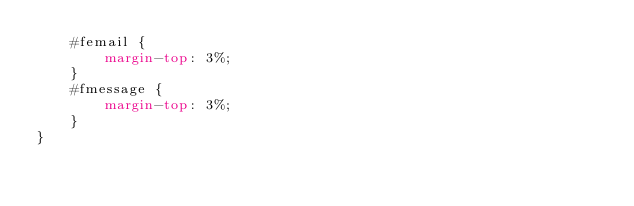<code> <loc_0><loc_0><loc_500><loc_500><_CSS_>    #femail {
        margin-top: 3%;
    }
    #fmessage {
        margin-top: 3%;
    }
}</code> 